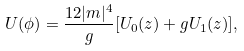Convert formula to latex. <formula><loc_0><loc_0><loc_500><loc_500>U ( \phi ) = \frac { 1 2 | m | ^ { 4 } } { g } [ U _ { 0 } ( z ) + g U _ { 1 } ( z ) ] ,</formula> 